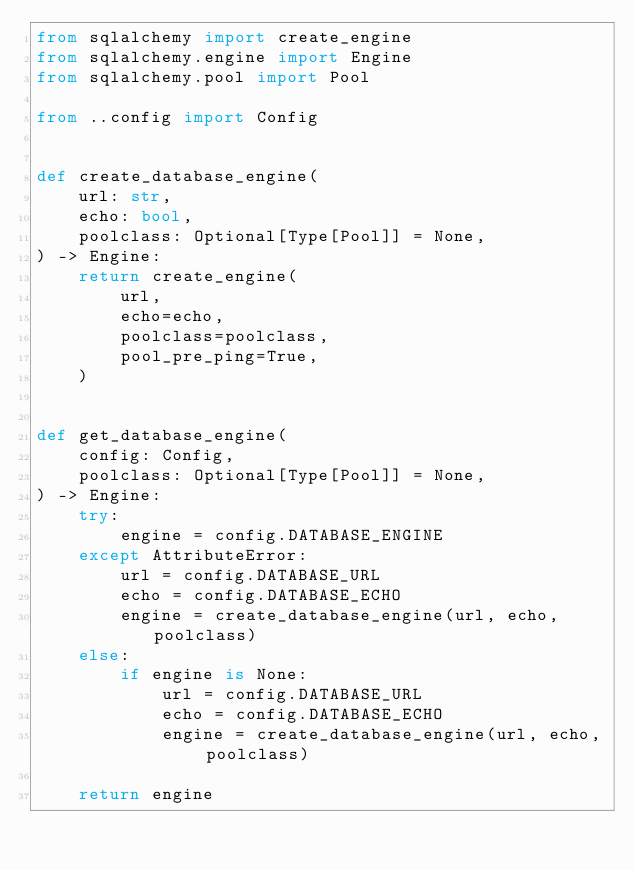<code> <loc_0><loc_0><loc_500><loc_500><_Python_>from sqlalchemy import create_engine
from sqlalchemy.engine import Engine
from sqlalchemy.pool import Pool

from ..config import Config


def create_database_engine(
    url: str,
    echo: bool,
    poolclass: Optional[Type[Pool]] = None,
) -> Engine:
    return create_engine(
        url,
        echo=echo,
        poolclass=poolclass,
        pool_pre_ping=True,
    )


def get_database_engine(
    config: Config,
    poolclass: Optional[Type[Pool]] = None,
) -> Engine:
    try:
        engine = config.DATABASE_ENGINE
    except AttributeError:
        url = config.DATABASE_URL
        echo = config.DATABASE_ECHO
        engine = create_database_engine(url, echo, poolclass)
    else:
        if engine is None:
            url = config.DATABASE_URL
            echo = config.DATABASE_ECHO
            engine = create_database_engine(url, echo, poolclass)

    return engine
</code> 